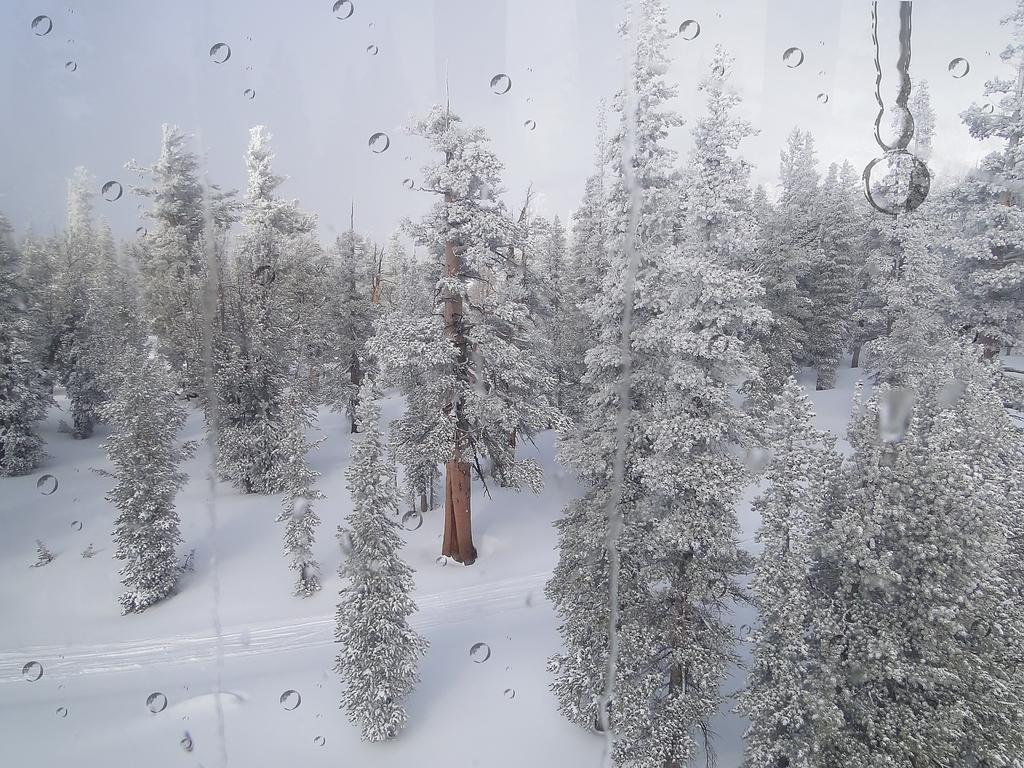What is present on the wall in the image? There is a poster in the image. What type of environment is depicted in the image? There are trees on the snow surface in the image, indicating a snowy environment. What is the primary characteristic of the ground in the image? There is snow visible in the image. What can be seen on the poster in the image? There are water droplets on the poster in the image. What type of discussion is taking place in the image? There is no discussion taking place in the image; it features a poster with water droplets on it in a snowy environment. Who is the achiever mentioned in the image? There is no mention of an achiever in the image; it only shows a poster with water droplets on it in a snowy environment. 